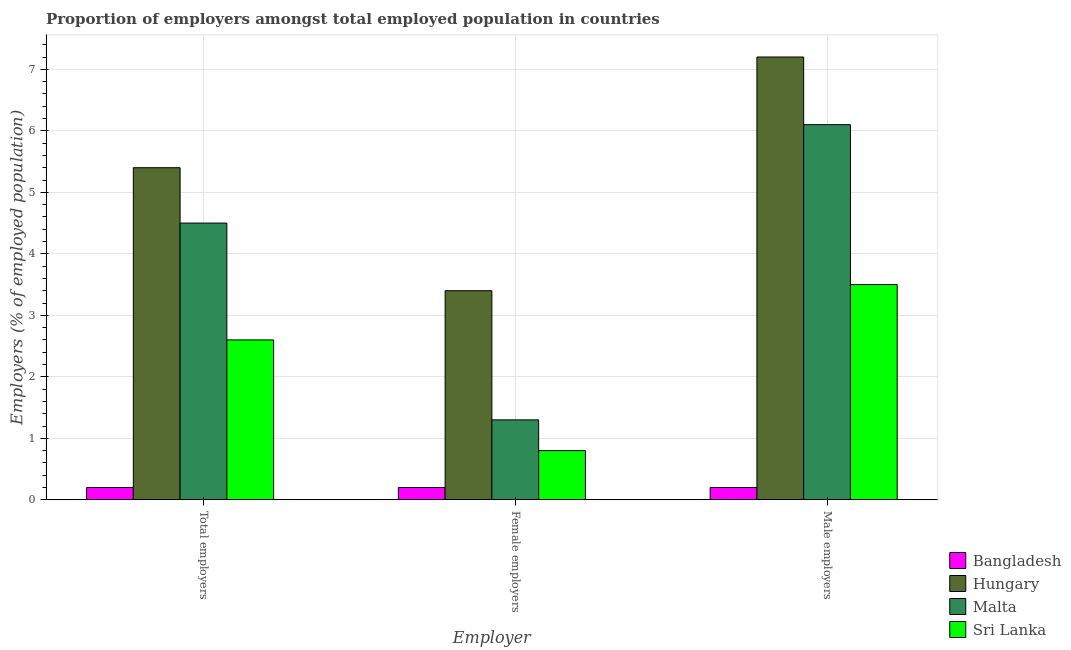Are the number of bars per tick equal to the number of legend labels?
Provide a succinct answer. Yes. How many bars are there on the 2nd tick from the left?
Keep it short and to the point. 4. How many bars are there on the 2nd tick from the right?
Your response must be concise. 4. What is the label of the 3rd group of bars from the left?
Give a very brief answer. Male employers. What is the percentage of total employers in Bangladesh?
Give a very brief answer. 0.2. Across all countries, what is the maximum percentage of male employers?
Your answer should be very brief. 7.2. Across all countries, what is the minimum percentage of total employers?
Give a very brief answer. 0.2. In which country was the percentage of female employers maximum?
Keep it short and to the point. Hungary. What is the total percentage of female employers in the graph?
Give a very brief answer. 5.7. What is the difference between the percentage of male employers in Bangladesh and that in Sri Lanka?
Keep it short and to the point. -3.3. What is the difference between the percentage of total employers in Sri Lanka and the percentage of female employers in Bangladesh?
Offer a terse response. 2.4. What is the average percentage of female employers per country?
Your answer should be very brief. 1.43. What is the difference between the percentage of total employers and percentage of female employers in Malta?
Your answer should be very brief. 3.2. In how many countries, is the percentage of female employers greater than 5.2 %?
Ensure brevity in your answer.  0. What is the ratio of the percentage of female employers in Hungary to that in Sri Lanka?
Make the answer very short. 4.25. Is the percentage of total employers in Malta less than that in Hungary?
Make the answer very short. Yes. Is the difference between the percentage of total employers in Hungary and Malta greater than the difference between the percentage of male employers in Hungary and Malta?
Provide a succinct answer. No. What is the difference between the highest and the second highest percentage of female employers?
Make the answer very short. 2.1. What is the difference between the highest and the lowest percentage of total employers?
Your answer should be very brief. 5.2. In how many countries, is the percentage of total employers greater than the average percentage of total employers taken over all countries?
Keep it short and to the point. 2. What does the 4th bar from the left in Female employers represents?
Give a very brief answer. Sri Lanka. How many countries are there in the graph?
Give a very brief answer. 4. Are the values on the major ticks of Y-axis written in scientific E-notation?
Provide a short and direct response. No. Does the graph contain any zero values?
Your answer should be compact. No. Does the graph contain grids?
Offer a very short reply. Yes. How are the legend labels stacked?
Keep it short and to the point. Vertical. What is the title of the graph?
Offer a very short reply. Proportion of employers amongst total employed population in countries. Does "Saudi Arabia" appear as one of the legend labels in the graph?
Your response must be concise. No. What is the label or title of the X-axis?
Keep it short and to the point. Employer. What is the label or title of the Y-axis?
Ensure brevity in your answer.  Employers (% of employed population). What is the Employers (% of employed population) of Bangladesh in Total employers?
Give a very brief answer. 0.2. What is the Employers (% of employed population) of Hungary in Total employers?
Offer a terse response. 5.4. What is the Employers (% of employed population) of Sri Lanka in Total employers?
Your response must be concise. 2.6. What is the Employers (% of employed population) of Bangladesh in Female employers?
Make the answer very short. 0.2. What is the Employers (% of employed population) of Hungary in Female employers?
Offer a terse response. 3.4. What is the Employers (% of employed population) in Malta in Female employers?
Provide a short and direct response. 1.3. What is the Employers (% of employed population) in Sri Lanka in Female employers?
Offer a very short reply. 0.8. What is the Employers (% of employed population) in Bangladesh in Male employers?
Make the answer very short. 0.2. What is the Employers (% of employed population) in Hungary in Male employers?
Offer a terse response. 7.2. What is the Employers (% of employed population) of Malta in Male employers?
Provide a short and direct response. 6.1. What is the Employers (% of employed population) of Sri Lanka in Male employers?
Your answer should be compact. 3.5. Across all Employer, what is the maximum Employers (% of employed population) of Bangladesh?
Offer a very short reply. 0.2. Across all Employer, what is the maximum Employers (% of employed population) of Hungary?
Your response must be concise. 7.2. Across all Employer, what is the maximum Employers (% of employed population) in Malta?
Offer a terse response. 6.1. Across all Employer, what is the minimum Employers (% of employed population) of Bangladesh?
Make the answer very short. 0.2. Across all Employer, what is the minimum Employers (% of employed population) in Hungary?
Make the answer very short. 3.4. Across all Employer, what is the minimum Employers (% of employed population) of Malta?
Your answer should be compact. 1.3. Across all Employer, what is the minimum Employers (% of employed population) in Sri Lanka?
Provide a succinct answer. 0.8. What is the difference between the Employers (% of employed population) of Bangladesh in Total employers and that in Female employers?
Ensure brevity in your answer.  0. What is the difference between the Employers (% of employed population) of Bangladesh in Total employers and that in Male employers?
Provide a short and direct response. 0. What is the difference between the Employers (% of employed population) in Malta in Total employers and that in Male employers?
Your answer should be compact. -1.6. What is the difference between the Employers (% of employed population) of Malta in Female employers and that in Male employers?
Offer a very short reply. -4.8. What is the difference between the Employers (% of employed population) in Sri Lanka in Female employers and that in Male employers?
Give a very brief answer. -2.7. What is the difference between the Employers (% of employed population) of Bangladesh in Total employers and the Employers (% of employed population) of Hungary in Female employers?
Your answer should be compact. -3.2. What is the difference between the Employers (% of employed population) in Bangladesh in Total employers and the Employers (% of employed population) in Malta in Female employers?
Give a very brief answer. -1.1. What is the difference between the Employers (% of employed population) in Hungary in Total employers and the Employers (% of employed population) in Malta in Female employers?
Give a very brief answer. 4.1. What is the difference between the Employers (% of employed population) in Hungary in Total employers and the Employers (% of employed population) in Sri Lanka in Female employers?
Offer a very short reply. 4.6. What is the difference between the Employers (% of employed population) of Malta in Total employers and the Employers (% of employed population) of Sri Lanka in Female employers?
Make the answer very short. 3.7. What is the difference between the Employers (% of employed population) of Bangladesh in Female employers and the Employers (% of employed population) of Hungary in Male employers?
Ensure brevity in your answer.  -7. What is the difference between the Employers (% of employed population) in Bangladesh in Female employers and the Employers (% of employed population) in Malta in Male employers?
Your response must be concise. -5.9. What is the difference between the Employers (% of employed population) in Hungary in Female employers and the Employers (% of employed population) in Sri Lanka in Male employers?
Provide a succinct answer. -0.1. What is the average Employers (% of employed population) of Bangladesh per Employer?
Your answer should be very brief. 0.2. What is the average Employers (% of employed population) in Hungary per Employer?
Offer a very short reply. 5.33. What is the average Employers (% of employed population) in Malta per Employer?
Provide a short and direct response. 3.97. What is the difference between the Employers (% of employed population) in Bangladesh and Employers (% of employed population) in Malta in Total employers?
Give a very brief answer. -4.3. What is the difference between the Employers (% of employed population) of Bangladesh and Employers (% of employed population) of Sri Lanka in Total employers?
Your answer should be compact. -2.4. What is the difference between the Employers (% of employed population) of Hungary and Employers (% of employed population) of Malta in Total employers?
Your answer should be compact. 0.9. What is the difference between the Employers (% of employed population) of Bangladesh and Employers (% of employed population) of Hungary in Female employers?
Give a very brief answer. -3.2. What is the difference between the Employers (% of employed population) in Hungary and Employers (% of employed population) in Sri Lanka in Female employers?
Offer a very short reply. 2.6. What is the difference between the Employers (% of employed population) in Bangladesh and Employers (% of employed population) in Hungary in Male employers?
Make the answer very short. -7. What is the ratio of the Employers (% of employed population) of Bangladesh in Total employers to that in Female employers?
Provide a short and direct response. 1. What is the ratio of the Employers (% of employed population) of Hungary in Total employers to that in Female employers?
Keep it short and to the point. 1.59. What is the ratio of the Employers (% of employed population) in Malta in Total employers to that in Female employers?
Give a very brief answer. 3.46. What is the ratio of the Employers (% of employed population) of Sri Lanka in Total employers to that in Female employers?
Your response must be concise. 3.25. What is the ratio of the Employers (% of employed population) in Bangladesh in Total employers to that in Male employers?
Make the answer very short. 1. What is the ratio of the Employers (% of employed population) of Malta in Total employers to that in Male employers?
Your answer should be compact. 0.74. What is the ratio of the Employers (% of employed population) in Sri Lanka in Total employers to that in Male employers?
Your answer should be compact. 0.74. What is the ratio of the Employers (% of employed population) of Hungary in Female employers to that in Male employers?
Your answer should be compact. 0.47. What is the ratio of the Employers (% of employed population) in Malta in Female employers to that in Male employers?
Keep it short and to the point. 0.21. What is the ratio of the Employers (% of employed population) in Sri Lanka in Female employers to that in Male employers?
Your response must be concise. 0.23. What is the difference between the highest and the second highest Employers (% of employed population) of Sri Lanka?
Your answer should be compact. 0.9. What is the difference between the highest and the lowest Employers (% of employed population) in Bangladesh?
Your response must be concise. 0. What is the difference between the highest and the lowest Employers (% of employed population) in Sri Lanka?
Make the answer very short. 2.7. 